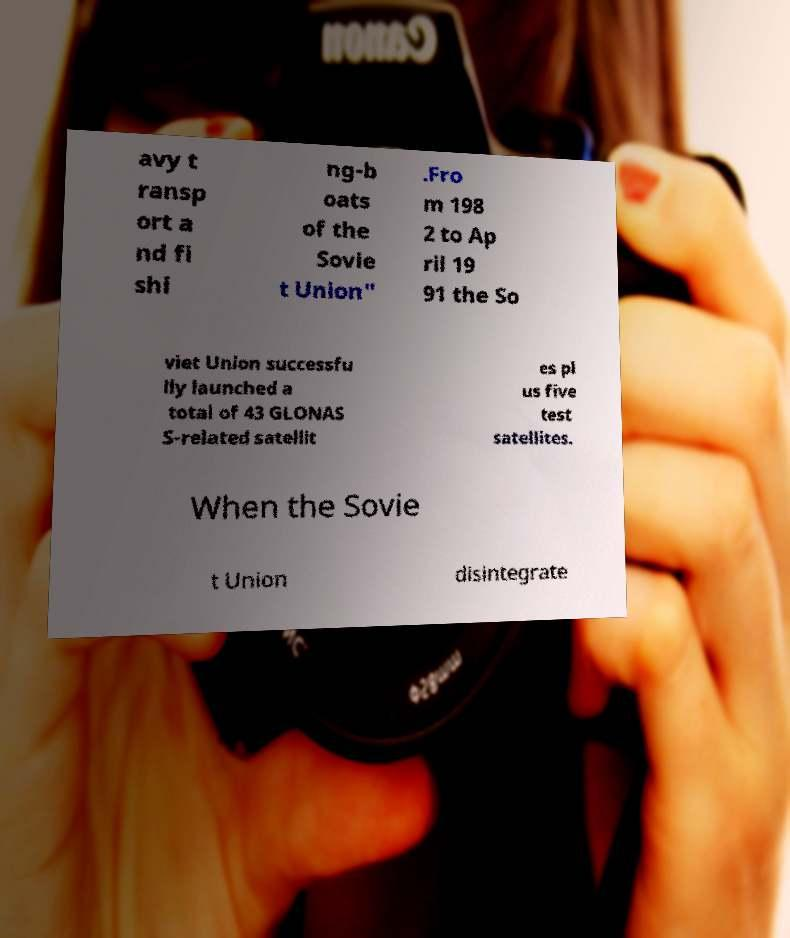Can you read and provide the text displayed in the image?This photo seems to have some interesting text. Can you extract and type it out for me? avy t ransp ort a nd fi shi ng-b oats of the Sovie t Union" .Fro m 198 2 to Ap ril 19 91 the So viet Union successfu lly launched a total of 43 GLONAS S-related satellit es pl us five test satellites. When the Sovie t Union disintegrate 